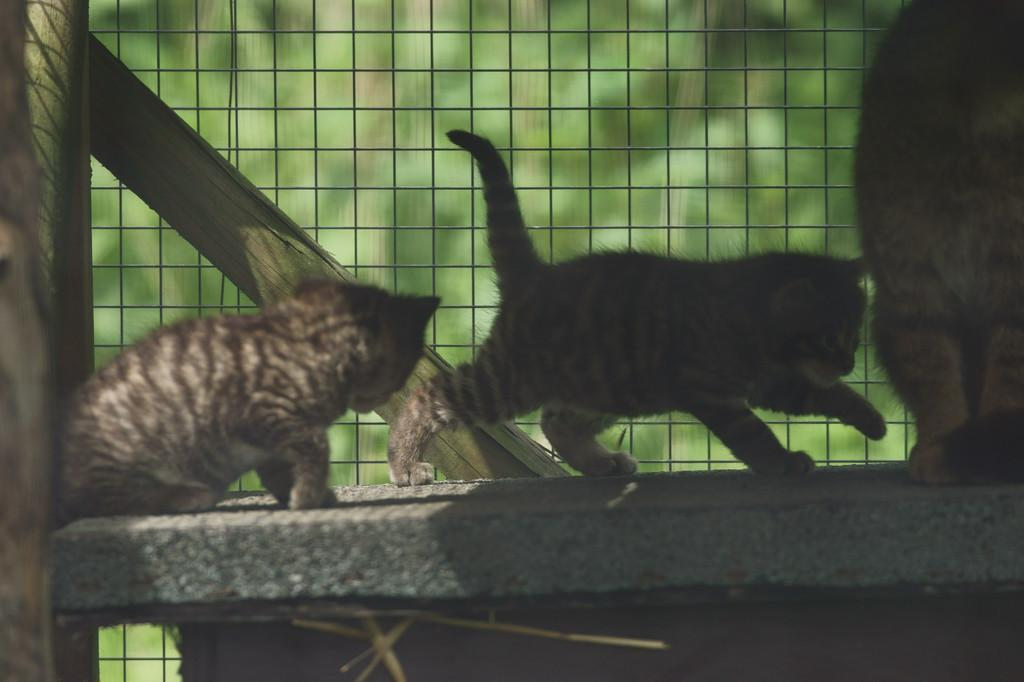What is located in the center of the image? There are animals in the center of the image. Where are the animals positioned in the image? The animals are on the floor. What is behind the animals in the image? There is a wooden stand behind the animals. What type of barrier is present in the image? There is a fence in the image. How would you describe the background of the image? The background of the image is blurry. What type of tooth is visible in the image? There is no tooth present in the image. How many forks can be seen in the image? There are no forks present in the image. 